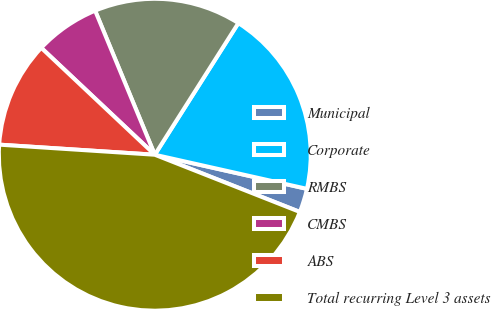<chart> <loc_0><loc_0><loc_500><loc_500><pie_chart><fcel>Municipal<fcel>Corporate<fcel>RMBS<fcel>CMBS<fcel>ABS<fcel>Total recurring Level 3 assets<nl><fcel>2.47%<fcel>19.51%<fcel>15.25%<fcel>6.73%<fcel>10.99%<fcel>45.05%<nl></chart> 